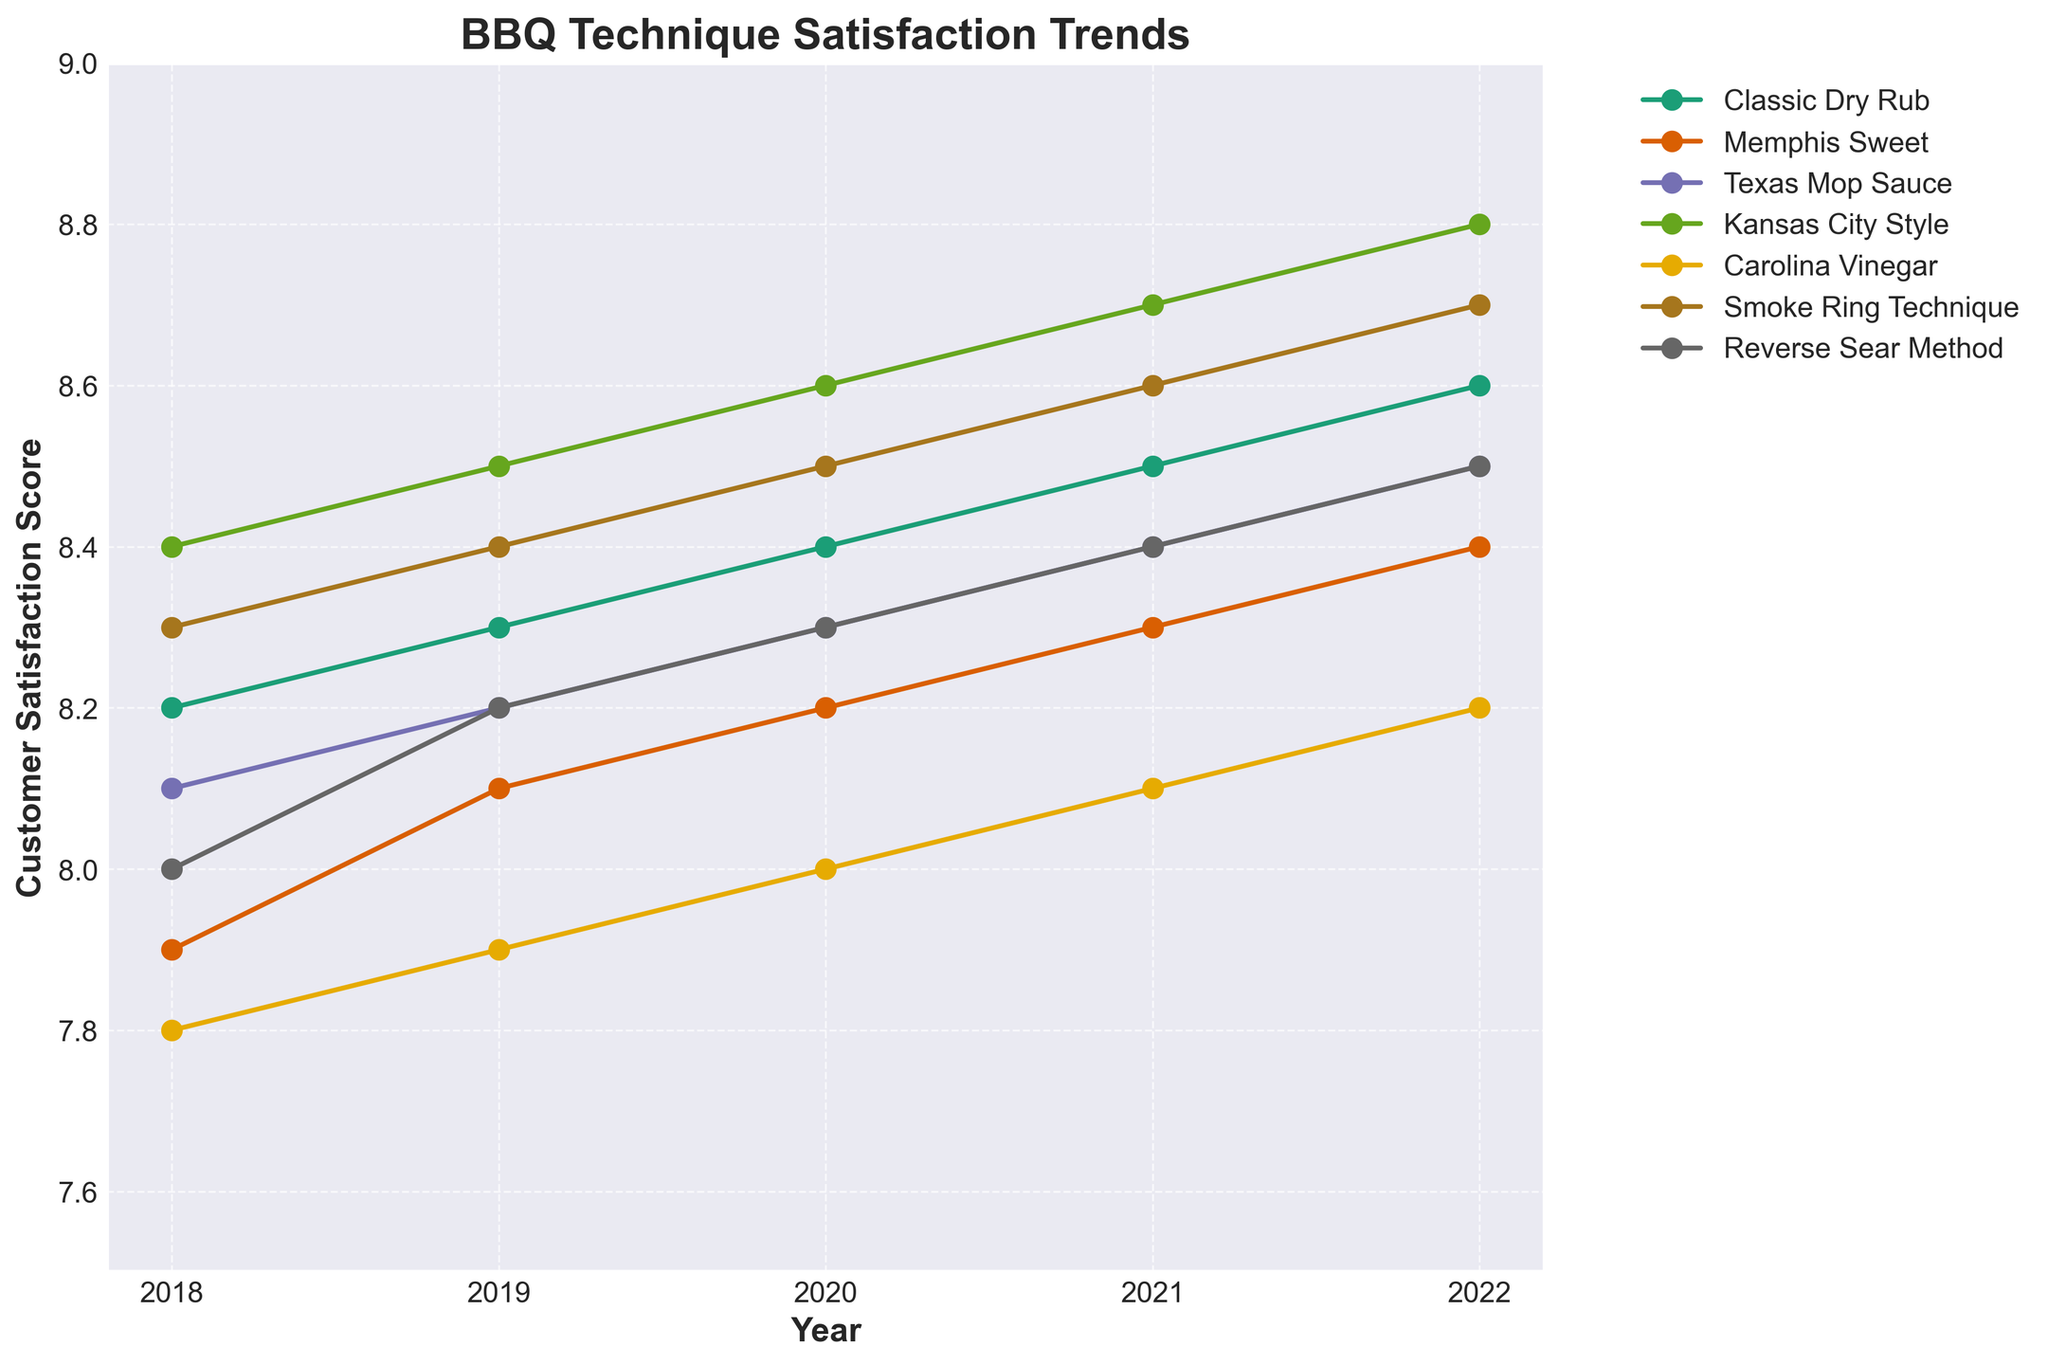Which barbecue technique had the highest customer satisfaction score in 2022? Look at the year 2022 on the horizontal axis and the highest point on the vertical axis among the plotted lines. The highest score is for Kansas City Style.
Answer: Kansas City Style Which technique had the most consistent customer satisfaction scores over the past 5 years? Compare the variability in satisfaction scores of each technique over the years. The Classic Dry Rub technique shows very consistent scores with minimal changes.
Answer: Classic Dry Rub How did the Memphis Sweet's satisfaction score change from 2018 to 2022? Observe the satisfaction scores of Memphis Sweet in 2018 (7.9) and 2022 (8.4). Compute the difference: 8.4 - 7.9 = 0.5.
Answer: Increased by 0.5 Between the Smoke Ring Technique and Texas Mop Sauce, which one consistently had higher satisfaction scores over the years? Compare the satisfaction scores of both techniques year by year. Smoke Ring Technique had consistently higher scores than Texas Mop Sauce.
Answer: Smoke Ring Technique What is the average customer satisfaction score of Kansas City Style over the five years? Add up all satisfaction scores of Kansas City Style from 2018 to 2022: (8.4 + 8.5 + 8.6 + 8.7 + 8.8) = 43.0. Then divide by the number of years: 43.0 / 5 = 8.6.
Answer: 8.6 Which two techniques show the greatest improvement in customer satisfaction from 2018 to 2022? Calculate the difference in satisfaction scores from 2018 to 2022 for each technique and compare: Kansas City Style (8.8-8.4=0.4), Carolina Vinegar (8.2-7.8=0.4).
Answer: Kansas City Style and Carolina Vinegar Which year had the highest overall customer satisfaction score for all techniques combined? Add satisfaction scores of all techniques for each year: 2018 (56.7), 2019 (57.6), 2020 (58.3), 2021 (58.8), 2022 (59.7). The year 2022 has the highest combined score.
Answer: 2022 Identify the two techniques with the closest satisfaction scores in 2020 and provide the difference. Look at the scores for 2020 and find the smallest difference: Smoke Ring Technique (8.5) and Kansas City Style (8.6) with a difference of 8.6-8.5=0.1.
Answer: Smoke Ring Technique and Kansas City Style with a difference of 0.1 